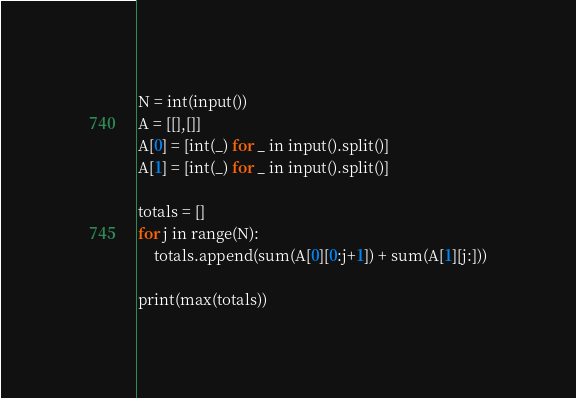<code> <loc_0><loc_0><loc_500><loc_500><_Python_>N = int(input())
A = [[],[]]
A[0] = [int(_) for _ in input().split()]
A[1] = [int(_) for _ in input().split()]

totals = []
for j in range(N):
    totals.append(sum(A[0][0:j+1]) + sum(A[1][j:]))

print(max(totals))</code> 